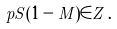<formula> <loc_0><loc_0><loc_500><loc_500>p S ( 1 - M ) \in Z \, .</formula> 